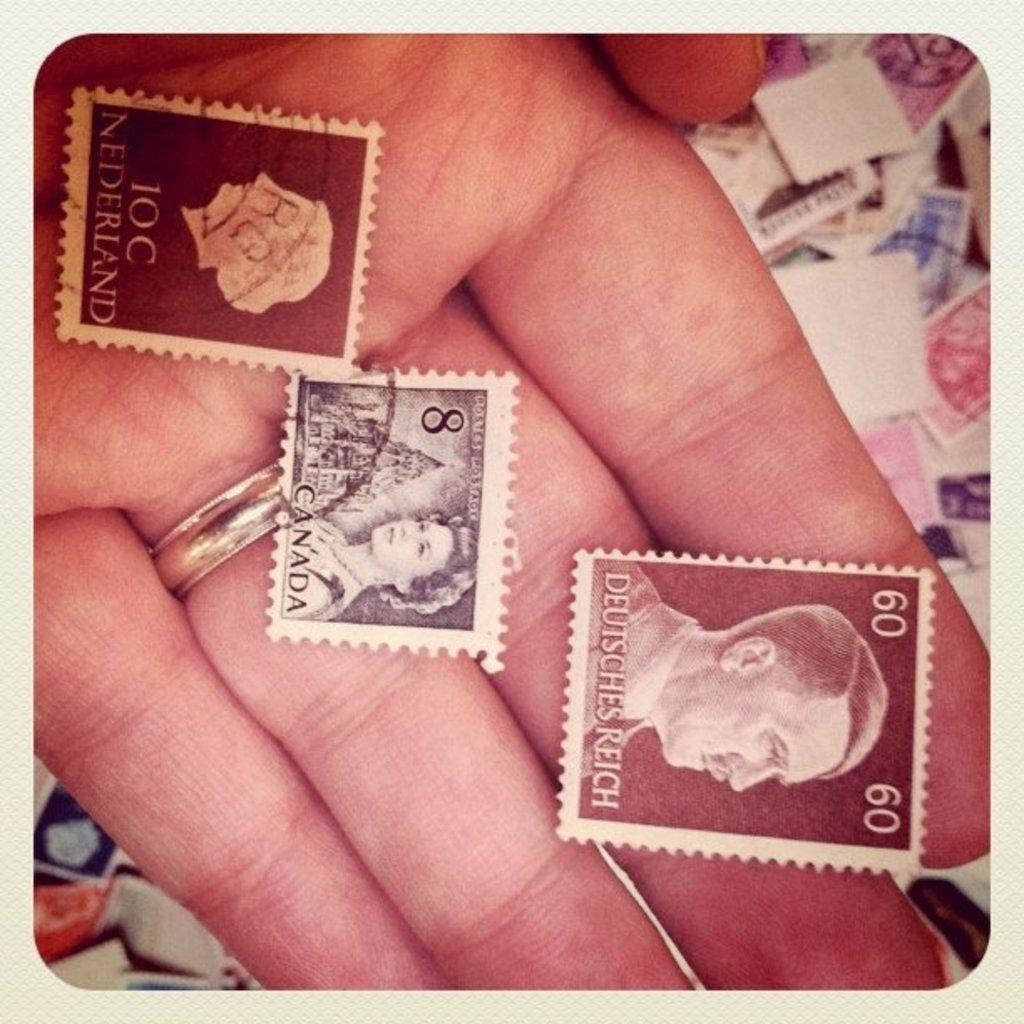What can be seen in the image related to a person's hand? There is a person's hand in the image, and it has three stamps. Are there any other stamps visible in the image? Yes, there are additional stamps below the hand. Where is the mailbox located in the image? There is no mailbox present in the image. How does the road affect the person's memory in the image? There is no road or memory-related information present in the image. 